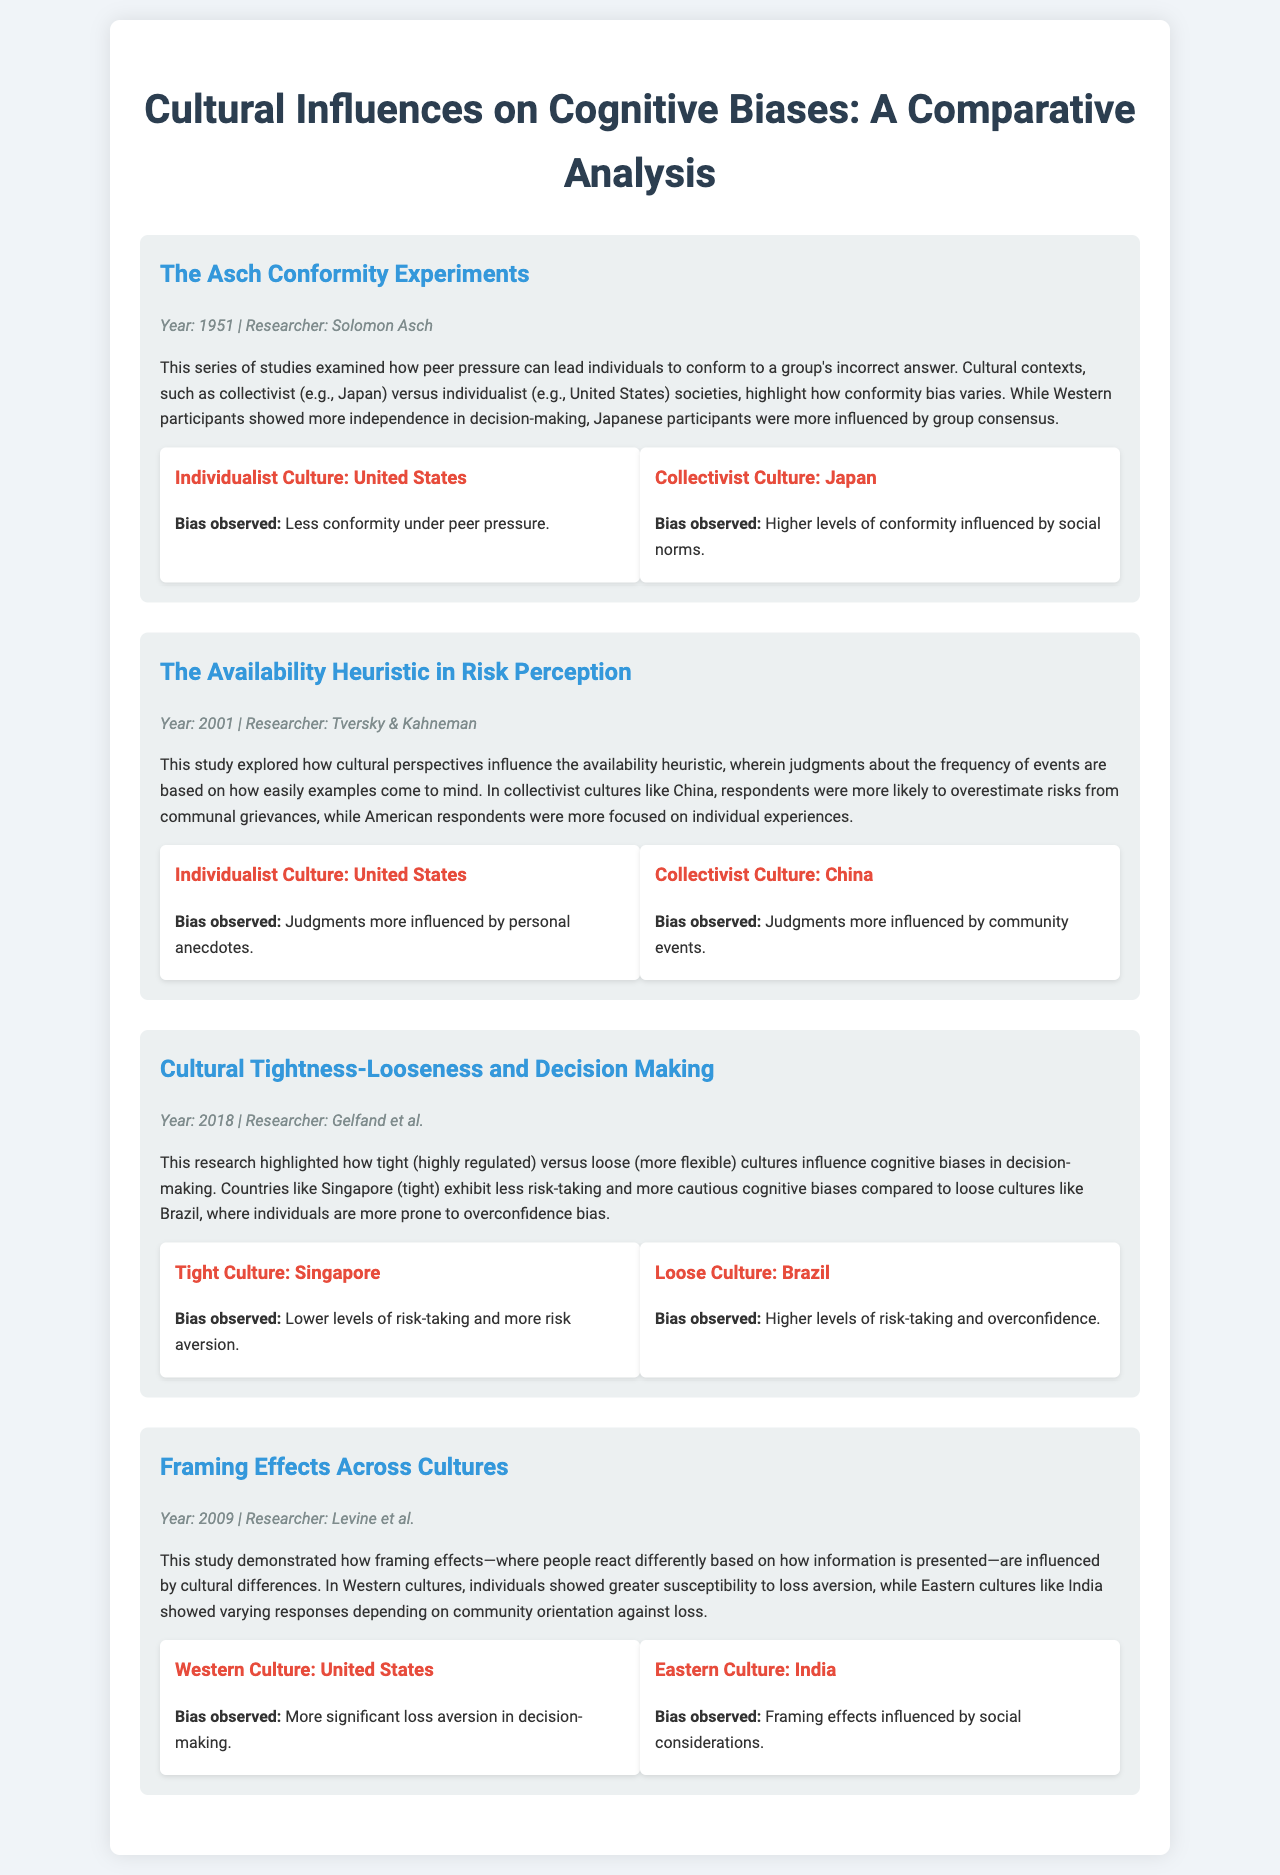What year did the Asch Conformity Experiments take place? The year is explicitly mentioned in the document under the case study section for Asch's work.
Answer: 1951 Who were the researchers involved in the Availability Heuristic study? The names of the researchers are listed in the case study description.
Answer: Tversky & Kahneman What type of cultural bias was observed in the individualist culture of the United States regarding conformity? The document states the specific bias observed for each cultural context in the respective sections.
Answer: Less conformity under peer pressure What is the main finding of the Cultural Tightness-Looseness study in relation to risk-taking? The findings highlight key differences in risk preferences between tight and loose cultures in the documented research.
Answer: Lower levels of risk-taking Which culture was associated with higher levels of overconfidence bias? The document explicitly links the observed biases to the respective cultures studied.
Answer: Brazil What phenomenon did the study by Levine et al. explore regarding cultural differences? The document discusses the context of the study and the specific cognitive bias investigated within different cultures.
Answer: Framing effects In what year was the Cultural Tightness-Looseness research conducted? The year can be found in the metadata of the case study section specifically mentioning Gelfand et al.'s research.
Answer: 2018 What cognitive bias was highlighted for the collectivist culture of China regarding risk perception? The document directly states the bias related to availability heuristic findings for the respective cultures examined.
Answer: Judgments more influenced by community events 